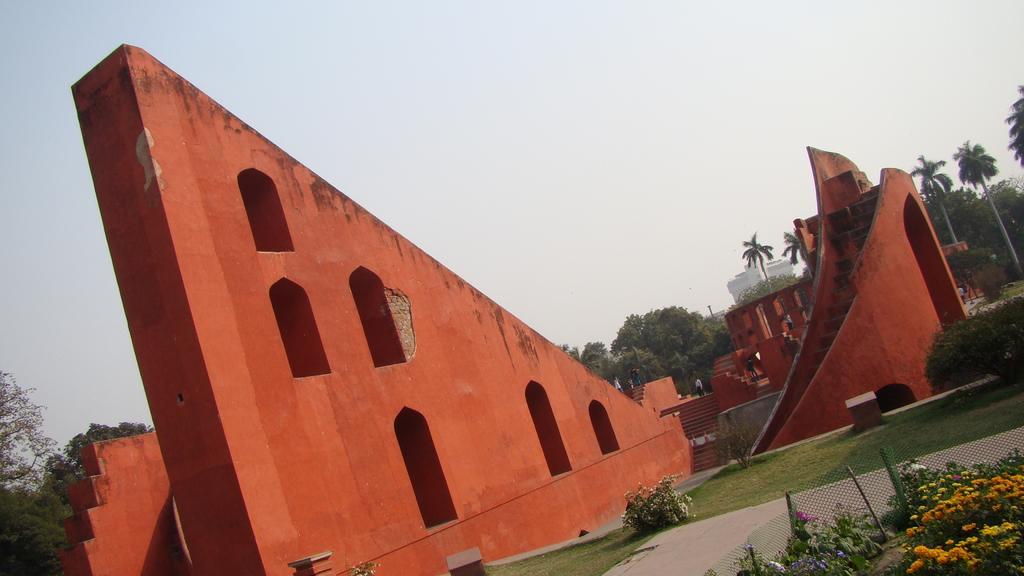Describe this image in one or two sentences. This picture is clicked outside. On the left we can see the wall and on the right we can see the staircase, building and group of persons and we can see the plants, green grass, flowers, mesh and some other objects. In the background we can see the sky, trees, building and group of persons and some other objects. 